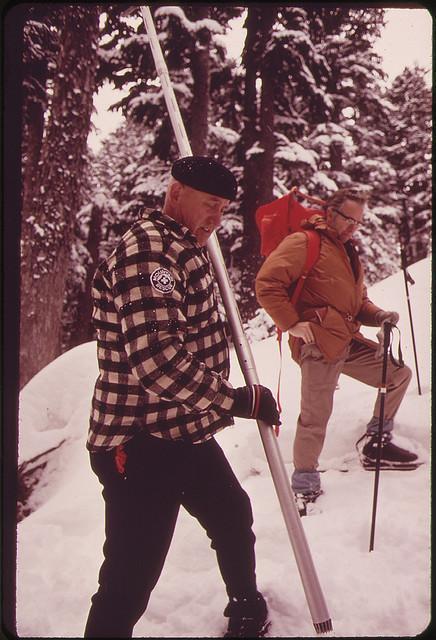How many people are there?
Give a very brief answer. 2. 